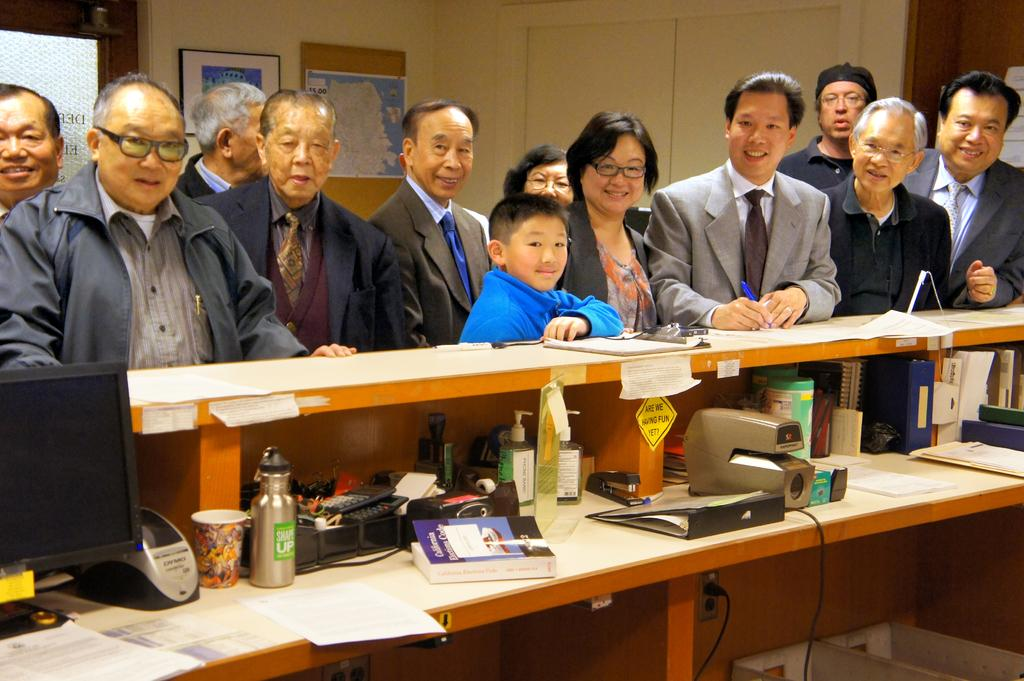How many people are in the image? There is a group of people in the image. What are the people standing in front of? The people are standing in front of a desk. What can be seen on the desk? There is a monitor and a bottle on the desk, along with other objects. How many roses are on the desk in the image? There are no roses present on the desk in the image. What type of sheep can be seen in the image? There are no sheep present in the image. 